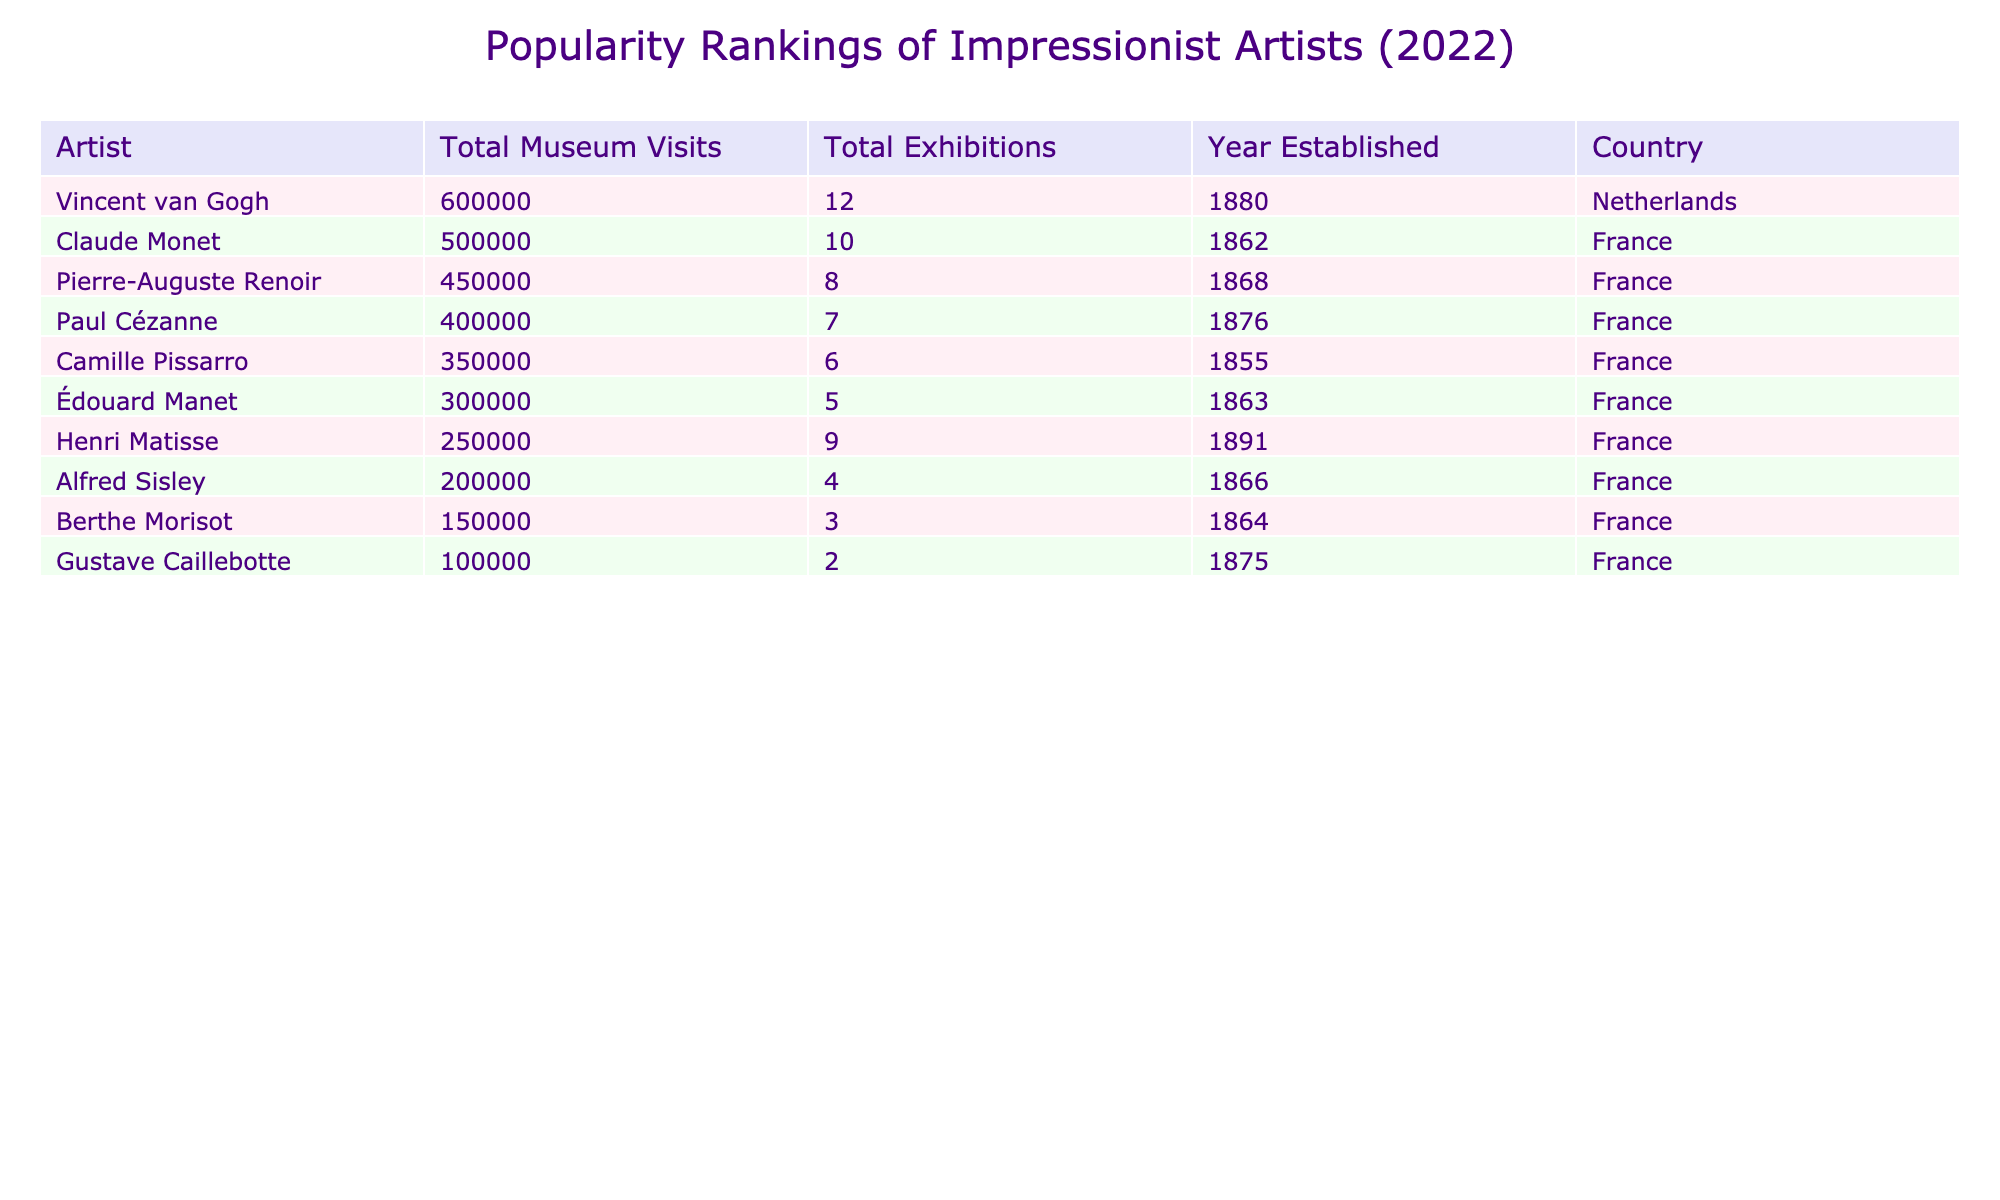What artist had the highest number of total museum visits in 2022? Claude Monet had the highest number of total museum visits with 500,000. This is the highest figure listed in the 'Total Museum Visits' column.
Answer: Claude Monet Which artist had the least total exhibitions in 2022? Berthe Morisot had the least total exhibitions with a total of 3, as this is the lowest number found in the 'Total Exhibitions' column.
Answer: Berthe Morisot How many total museum visits were there for Vincent van Gogh and Paul Cézanne combined? Vincent van Gogh had 600,000 total museum visits, and Paul Cézanne had 400,000. Adding these figures together: 600,000 + 400,000 = 1,000,000.
Answer: 1,000,000 What is the difference in total museum visits between Claude Monet and Alfred Sisley? Claude Monet had 500,000 total museum visits while Alfred Sisley had 200,000. To find the difference: 500,000 - 200,000 = 300,000.
Answer: 300,000 Are there more total exhibitions for artists from France compared to those from the Netherlands? The total exhibitions for French artists (Claude Monet, Pierre-Auguste Renoir, Camille Pissarro, Alfred Sisley, Édouard Manet, Berthe Morisot, Gustave Caillebotte, Paul Cézanne, Henri Matisse) sum to 60 (10 + 8 + 6 + 4 + 5 + 3 + 2 + 7 + 9 = 60). The only artist from the Netherlands is Vincent van Gogh with 12 exhibitions. Since 60 > 12, the statement is true.
Answer: Yes If you were to rank the artists by total museum visits, which would be the third artist on the list? Listing the artists by total museum visits in descending order, the top three are Claude Monet (500,000), Vincent van Gogh (600,000), and then Paul Cézanne (400,000). Therefore, Paul Cézanne is the third artist in ranking.
Answer: Paul Cézanne What is the average total museum visits of the artists listed in the table? To find the average, first sum all the museum visits: 500,000 + 450,000 + 350,000 + 200,000 + 300,000 + 150,000 + 100,000 + 400,000 + 250,000 + 600,000 = 3,000,000. Then divide by the number of artists (10): 3,000,000 / 10 = 300,000.
Answer: 300,000 Which artist had the highest total exhibitions, and how many did they have more than Berthe Morisot? Vincent van Gogh had the highest total exhibitions with 12. Berthe Morisot had 3 exhibitions. The difference is 12 - 3 = 9.
Answer: 9 Is there an artist who had more total exhibitions than the average total exhibitions of all artists? The average number of total exhibitions can be calculated as (10 + 8 + 6 + 4 + 5 + 3 + 2 + 7 + 9 + 12) / 10 = 6.6. Artists with more than 6.6 include Vincent van Gogh (12), Claude Monet (10), and Henri Matisse (9). Therefore, there are artists who meet the criteria.
Answer: Yes 